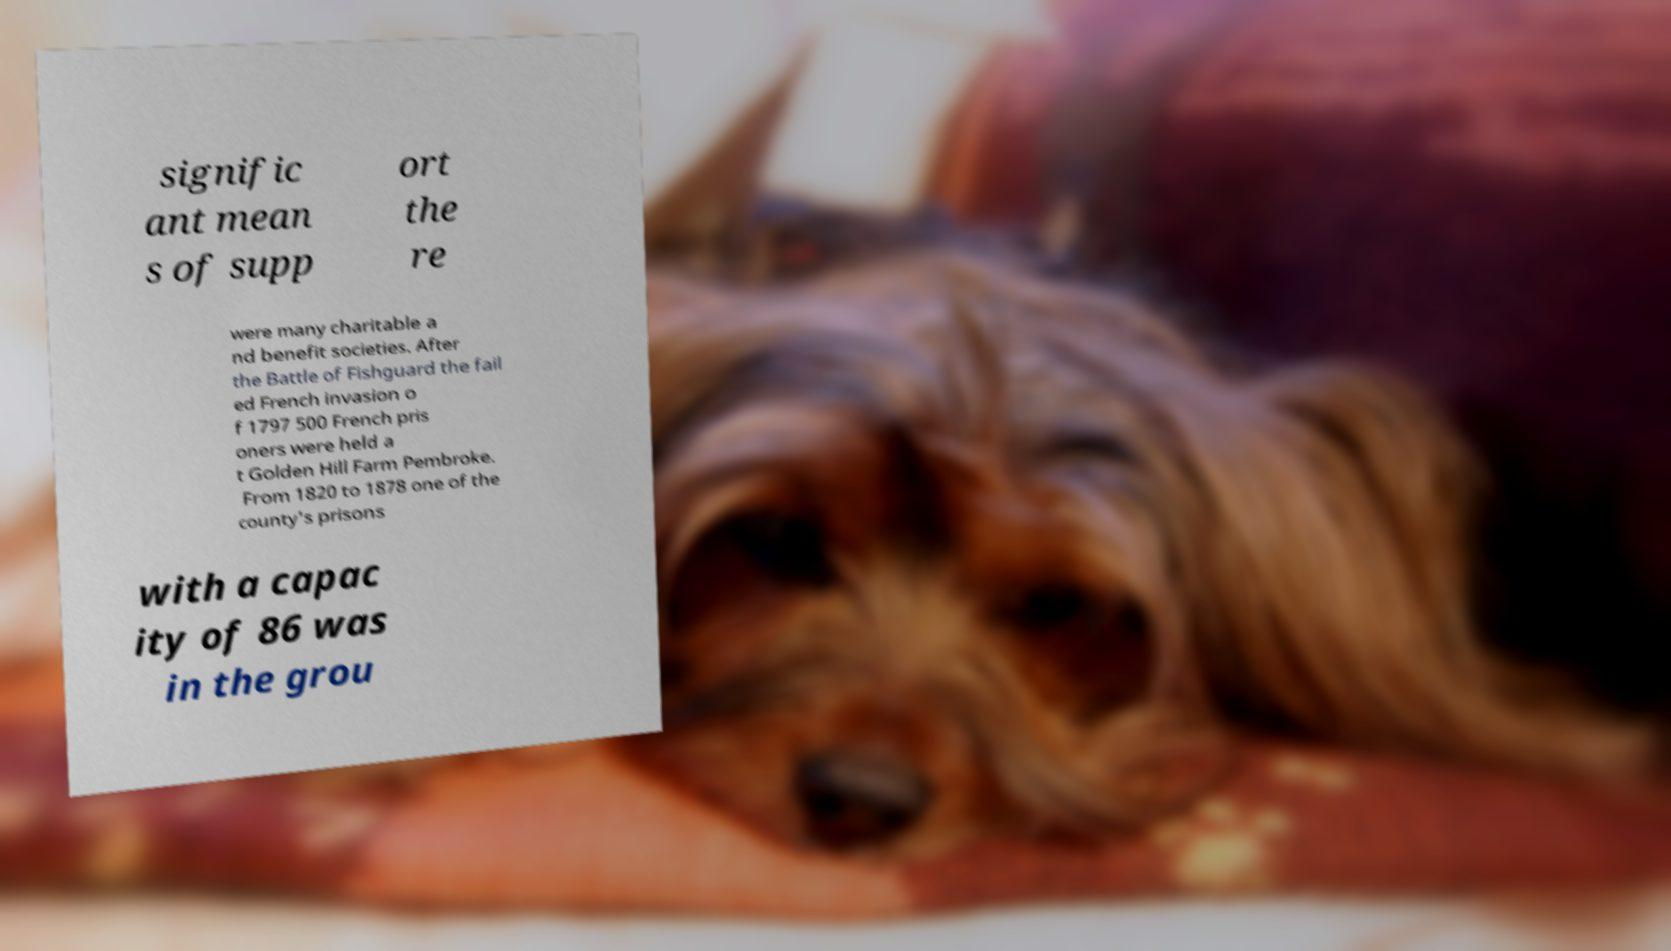Could you extract and type out the text from this image? signific ant mean s of supp ort the re were many charitable a nd benefit societies. After the Battle of Fishguard the fail ed French invasion o f 1797 500 French pris oners were held a t Golden Hill Farm Pembroke. From 1820 to 1878 one of the county's prisons with a capac ity of 86 was in the grou 